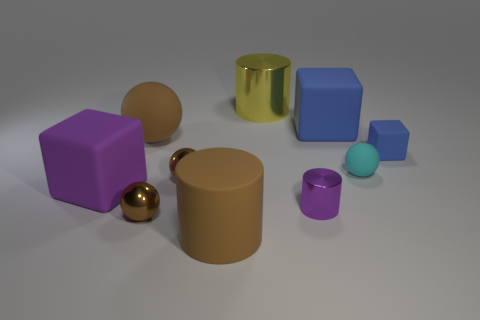Subtract all cyan blocks. How many brown spheres are left? 3 Subtract 1 balls. How many balls are left? 3 Subtract all cyan spheres. How many spheres are left? 3 Subtract all large brown spheres. How many spheres are left? 3 Subtract all red balls. Subtract all blue cylinders. How many balls are left? 4 Subtract all cylinders. How many objects are left? 7 Add 6 big rubber blocks. How many big rubber blocks are left? 8 Add 1 large matte objects. How many large matte objects exist? 5 Subtract 0 blue cylinders. How many objects are left? 10 Subtract all purple shiny objects. Subtract all cyan balls. How many objects are left? 8 